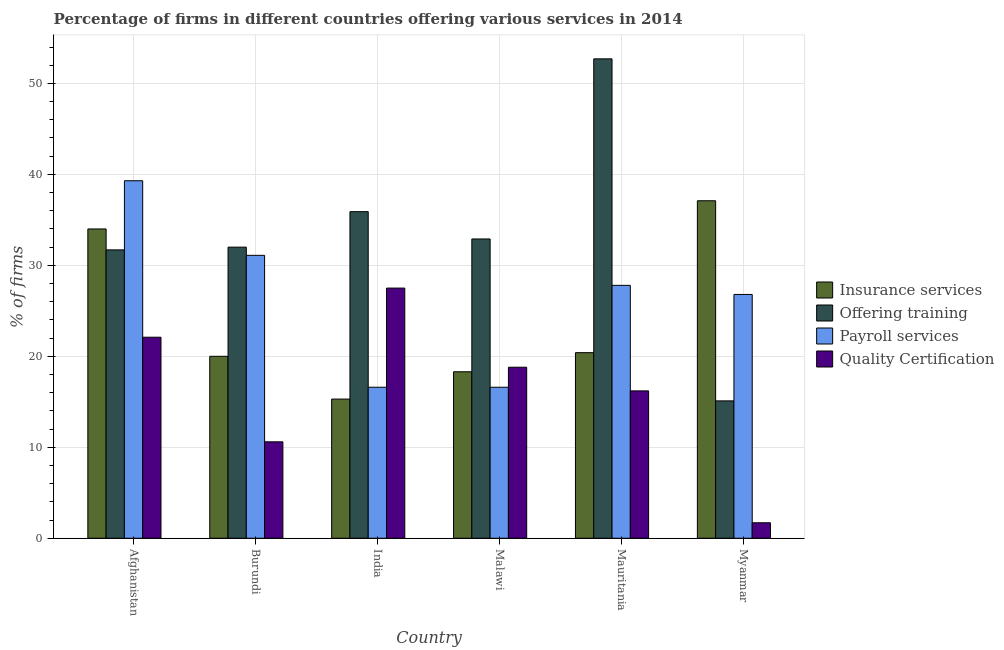Are the number of bars on each tick of the X-axis equal?
Your answer should be compact. Yes. What is the label of the 6th group of bars from the left?
Offer a terse response. Myanmar. What is the percentage of firms offering quality certification in Afghanistan?
Provide a short and direct response. 22.1. Across all countries, what is the maximum percentage of firms offering payroll services?
Your response must be concise. 39.3. Across all countries, what is the minimum percentage of firms offering insurance services?
Your answer should be compact. 15.3. In which country was the percentage of firms offering payroll services maximum?
Provide a succinct answer. Afghanistan. In which country was the percentage of firms offering training minimum?
Give a very brief answer. Myanmar. What is the total percentage of firms offering insurance services in the graph?
Keep it short and to the point. 145.1. What is the difference between the percentage of firms offering training in Burundi and that in India?
Your response must be concise. -3.9. What is the difference between the percentage of firms offering payroll services in Burundi and the percentage of firms offering quality certification in Myanmar?
Your answer should be very brief. 29.4. What is the average percentage of firms offering payroll services per country?
Your answer should be compact. 26.37. What is the difference between the percentage of firms offering quality certification and percentage of firms offering training in India?
Make the answer very short. -8.4. In how many countries, is the percentage of firms offering training greater than 4 %?
Your answer should be compact. 6. What is the ratio of the percentage of firms offering training in Burundi to that in Malawi?
Your response must be concise. 0.97. Is the percentage of firms offering training in Burundi less than that in India?
Give a very brief answer. Yes. What is the difference between the highest and the second highest percentage of firms offering training?
Make the answer very short. 16.8. What is the difference between the highest and the lowest percentage of firms offering training?
Ensure brevity in your answer.  37.6. What does the 2nd bar from the left in India represents?
Make the answer very short. Offering training. What does the 2nd bar from the right in Mauritania represents?
Ensure brevity in your answer.  Payroll services. Is it the case that in every country, the sum of the percentage of firms offering insurance services and percentage of firms offering training is greater than the percentage of firms offering payroll services?
Offer a terse response. Yes. How many bars are there?
Make the answer very short. 24. Are all the bars in the graph horizontal?
Ensure brevity in your answer.  No. How many countries are there in the graph?
Your answer should be compact. 6. Are the values on the major ticks of Y-axis written in scientific E-notation?
Offer a very short reply. No. Where does the legend appear in the graph?
Your answer should be compact. Center right. What is the title of the graph?
Make the answer very short. Percentage of firms in different countries offering various services in 2014. What is the label or title of the X-axis?
Make the answer very short. Country. What is the label or title of the Y-axis?
Provide a short and direct response. % of firms. What is the % of firms in Insurance services in Afghanistan?
Provide a short and direct response. 34. What is the % of firms in Offering training in Afghanistan?
Keep it short and to the point. 31.7. What is the % of firms of Payroll services in Afghanistan?
Ensure brevity in your answer.  39.3. What is the % of firms in Quality Certification in Afghanistan?
Offer a very short reply. 22.1. What is the % of firms in Insurance services in Burundi?
Provide a succinct answer. 20. What is the % of firms in Payroll services in Burundi?
Ensure brevity in your answer.  31.1. What is the % of firms of Insurance services in India?
Provide a short and direct response. 15.3. What is the % of firms in Offering training in India?
Keep it short and to the point. 35.9. What is the % of firms of Quality Certification in India?
Your answer should be compact. 27.5. What is the % of firms in Offering training in Malawi?
Give a very brief answer. 32.9. What is the % of firms of Insurance services in Mauritania?
Your answer should be very brief. 20.4. What is the % of firms of Offering training in Mauritania?
Your answer should be compact. 52.7. What is the % of firms of Payroll services in Mauritania?
Make the answer very short. 27.8. What is the % of firms of Quality Certification in Mauritania?
Provide a succinct answer. 16.2. What is the % of firms in Insurance services in Myanmar?
Keep it short and to the point. 37.1. What is the % of firms of Payroll services in Myanmar?
Ensure brevity in your answer.  26.8. What is the % of firms in Quality Certification in Myanmar?
Your answer should be very brief. 1.7. Across all countries, what is the maximum % of firms of Insurance services?
Offer a very short reply. 37.1. Across all countries, what is the maximum % of firms of Offering training?
Your answer should be very brief. 52.7. Across all countries, what is the maximum % of firms in Payroll services?
Ensure brevity in your answer.  39.3. Across all countries, what is the minimum % of firms of Insurance services?
Ensure brevity in your answer.  15.3. Across all countries, what is the minimum % of firms of Offering training?
Your answer should be very brief. 15.1. Across all countries, what is the minimum % of firms in Payroll services?
Ensure brevity in your answer.  16.6. What is the total % of firms of Insurance services in the graph?
Your answer should be compact. 145.1. What is the total % of firms of Offering training in the graph?
Keep it short and to the point. 200.3. What is the total % of firms of Payroll services in the graph?
Offer a very short reply. 158.2. What is the total % of firms of Quality Certification in the graph?
Your response must be concise. 96.9. What is the difference between the % of firms in Insurance services in Afghanistan and that in Burundi?
Offer a terse response. 14. What is the difference between the % of firms of Offering training in Afghanistan and that in Burundi?
Provide a succinct answer. -0.3. What is the difference between the % of firms of Payroll services in Afghanistan and that in Burundi?
Your answer should be compact. 8.2. What is the difference between the % of firms in Offering training in Afghanistan and that in India?
Your answer should be compact. -4.2. What is the difference between the % of firms in Payroll services in Afghanistan and that in India?
Your answer should be compact. 22.7. What is the difference between the % of firms of Insurance services in Afghanistan and that in Malawi?
Make the answer very short. 15.7. What is the difference between the % of firms in Payroll services in Afghanistan and that in Malawi?
Give a very brief answer. 22.7. What is the difference between the % of firms in Insurance services in Afghanistan and that in Mauritania?
Ensure brevity in your answer.  13.6. What is the difference between the % of firms in Offering training in Afghanistan and that in Mauritania?
Ensure brevity in your answer.  -21. What is the difference between the % of firms of Quality Certification in Afghanistan and that in Mauritania?
Ensure brevity in your answer.  5.9. What is the difference between the % of firms in Insurance services in Afghanistan and that in Myanmar?
Give a very brief answer. -3.1. What is the difference between the % of firms of Offering training in Afghanistan and that in Myanmar?
Give a very brief answer. 16.6. What is the difference between the % of firms of Quality Certification in Afghanistan and that in Myanmar?
Keep it short and to the point. 20.4. What is the difference between the % of firms of Payroll services in Burundi and that in India?
Your answer should be compact. 14.5. What is the difference between the % of firms in Quality Certification in Burundi and that in India?
Provide a succinct answer. -16.9. What is the difference between the % of firms in Quality Certification in Burundi and that in Malawi?
Make the answer very short. -8.2. What is the difference between the % of firms in Offering training in Burundi and that in Mauritania?
Provide a succinct answer. -20.7. What is the difference between the % of firms of Payroll services in Burundi and that in Mauritania?
Provide a short and direct response. 3.3. What is the difference between the % of firms in Insurance services in Burundi and that in Myanmar?
Make the answer very short. -17.1. What is the difference between the % of firms of Quality Certification in Burundi and that in Myanmar?
Give a very brief answer. 8.9. What is the difference between the % of firms in Offering training in India and that in Malawi?
Provide a succinct answer. 3. What is the difference between the % of firms in Quality Certification in India and that in Malawi?
Ensure brevity in your answer.  8.7. What is the difference between the % of firms of Offering training in India and that in Mauritania?
Offer a terse response. -16.8. What is the difference between the % of firms in Quality Certification in India and that in Mauritania?
Give a very brief answer. 11.3. What is the difference between the % of firms in Insurance services in India and that in Myanmar?
Make the answer very short. -21.8. What is the difference between the % of firms in Offering training in India and that in Myanmar?
Make the answer very short. 20.8. What is the difference between the % of firms in Payroll services in India and that in Myanmar?
Ensure brevity in your answer.  -10.2. What is the difference between the % of firms of Quality Certification in India and that in Myanmar?
Provide a short and direct response. 25.8. What is the difference between the % of firms in Insurance services in Malawi and that in Mauritania?
Keep it short and to the point. -2.1. What is the difference between the % of firms in Offering training in Malawi and that in Mauritania?
Give a very brief answer. -19.8. What is the difference between the % of firms of Payroll services in Malawi and that in Mauritania?
Your answer should be compact. -11.2. What is the difference between the % of firms of Insurance services in Malawi and that in Myanmar?
Give a very brief answer. -18.8. What is the difference between the % of firms of Offering training in Malawi and that in Myanmar?
Your response must be concise. 17.8. What is the difference between the % of firms in Payroll services in Malawi and that in Myanmar?
Ensure brevity in your answer.  -10.2. What is the difference between the % of firms of Quality Certification in Malawi and that in Myanmar?
Offer a terse response. 17.1. What is the difference between the % of firms of Insurance services in Mauritania and that in Myanmar?
Provide a short and direct response. -16.7. What is the difference between the % of firms in Offering training in Mauritania and that in Myanmar?
Give a very brief answer. 37.6. What is the difference between the % of firms in Payroll services in Mauritania and that in Myanmar?
Keep it short and to the point. 1. What is the difference between the % of firms of Insurance services in Afghanistan and the % of firms of Quality Certification in Burundi?
Ensure brevity in your answer.  23.4. What is the difference between the % of firms in Offering training in Afghanistan and the % of firms in Quality Certification in Burundi?
Offer a terse response. 21.1. What is the difference between the % of firms of Payroll services in Afghanistan and the % of firms of Quality Certification in Burundi?
Offer a terse response. 28.7. What is the difference between the % of firms of Offering training in Afghanistan and the % of firms of Quality Certification in India?
Keep it short and to the point. 4.2. What is the difference between the % of firms in Payroll services in Afghanistan and the % of firms in Quality Certification in India?
Offer a terse response. 11.8. What is the difference between the % of firms of Insurance services in Afghanistan and the % of firms of Offering training in Malawi?
Provide a succinct answer. 1.1. What is the difference between the % of firms in Insurance services in Afghanistan and the % of firms in Payroll services in Malawi?
Offer a terse response. 17.4. What is the difference between the % of firms in Insurance services in Afghanistan and the % of firms in Quality Certification in Malawi?
Your answer should be compact. 15.2. What is the difference between the % of firms in Payroll services in Afghanistan and the % of firms in Quality Certification in Malawi?
Your answer should be very brief. 20.5. What is the difference between the % of firms of Insurance services in Afghanistan and the % of firms of Offering training in Mauritania?
Provide a short and direct response. -18.7. What is the difference between the % of firms of Payroll services in Afghanistan and the % of firms of Quality Certification in Mauritania?
Provide a short and direct response. 23.1. What is the difference between the % of firms in Insurance services in Afghanistan and the % of firms in Offering training in Myanmar?
Your answer should be very brief. 18.9. What is the difference between the % of firms of Insurance services in Afghanistan and the % of firms of Payroll services in Myanmar?
Offer a very short reply. 7.2. What is the difference between the % of firms of Insurance services in Afghanistan and the % of firms of Quality Certification in Myanmar?
Offer a very short reply. 32.3. What is the difference between the % of firms of Offering training in Afghanistan and the % of firms of Payroll services in Myanmar?
Your answer should be compact. 4.9. What is the difference between the % of firms in Payroll services in Afghanistan and the % of firms in Quality Certification in Myanmar?
Offer a very short reply. 37.6. What is the difference between the % of firms of Insurance services in Burundi and the % of firms of Offering training in India?
Provide a succinct answer. -15.9. What is the difference between the % of firms of Offering training in Burundi and the % of firms of Payroll services in Malawi?
Keep it short and to the point. 15.4. What is the difference between the % of firms of Offering training in Burundi and the % of firms of Quality Certification in Malawi?
Ensure brevity in your answer.  13.2. What is the difference between the % of firms in Insurance services in Burundi and the % of firms in Offering training in Mauritania?
Provide a short and direct response. -32.7. What is the difference between the % of firms in Insurance services in Burundi and the % of firms in Payroll services in Mauritania?
Give a very brief answer. -7.8. What is the difference between the % of firms of Offering training in Burundi and the % of firms of Payroll services in Mauritania?
Provide a succinct answer. 4.2. What is the difference between the % of firms in Offering training in Burundi and the % of firms in Quality Certification in Mauritania?
Ensure brevity in your answer.  15.8. What is the difference between the % of firms in Payroll services in Burundi and the % of firms in Quality Certification in Mauritania?
Provide a succinct answer. 14.9. What is the difference between the % of firms of Insurance services in Burundi and the % of firms of Payroll services in Myanmar?
Offer a very short reply. -6.8. What is the difference between the % of firms of Offering training in Burundi and the % of firms of Quality Certification in Myanmar?
Keep it short and to the point. 30.3. What is the difference between the % of firms in Payroll services in Burundi and the % of firms in Quality Certification in Myanmar?
Provide a succinct answer. 29.4. What is the difference between the % of firms of Insurance services in India and the % of firms of Offering training in Malawi?
Give a very brief answer. -17.6. What is the difference between the % of firms of Offering training in India and the % of firms of Payroll services in Malawi?
Provide a short and direct response. 19.3. What is the difference between the % of firms of Offering training in India and the % of firms of Quality Certification in Malawi?
Your answer should be very brief. 17.1. What is the difference between the % of firms of Payroll services in India and the % of firms of Quality Certification in Malawi?
Give a very brief answer. -2.2. What is the difference between the % of firms of Insurance services in India and the % of firms of Offering training in Mauritania?
Make the answer very short. -37.4. What is the difference between the % of firms in Insurance services in India and the % of firms in Payroll services in Mauritania?
Provide a succinct answer. -12.5. What is the difference between the % of firms of Insurance services in India and the % of firms of Quality Certification in Mauritania?
Provide a succinct answer. -0.9. What is the difference between the % of firms of Offering training in India and the % of firms of Quality Certification in Mauritania?
Your response must be concise. 19.7. What is the difference between the % of firms in Insurance services in India and the % of firms in Offering training in Myanmar?
Make the answer very short. 0.2. What is the difference between the % of firms in Insurance services in India and the % of firms in Payroll services in Myanmar?
Your answer should be very brief. -11.5. What is the difference between the % of firms in Offering training in India and the % of firms in Payroll services in Myanmar?
Keep it short and to the point. 9.1. What is the difference between the % of firms in Offering training in India and the % of firms in Quality Certification in Myanmar?
Keep it short and to the point. 34.2. What is the difference between the % of firms in Payroll services in India and the % of firms in Quality Certification in Myanmar?
Provide a succinct answer. 14.9. What is the difference between the % of firms in Insurance services in Malawi and the % of firms in Offering training in Mauritania?
Make the answer very short. -34.4. What is the difference between the % of firms in Insurance services in Malawi and the % of firms in Payroll services in Mauritania?
Your response must be concise. -9.5. What is the difference between the % of firms of Insurance services in Malawi and the % of firms of Quality Certification in Mauritania?
Keep it short and to the point. 2.1. What is the difference between the % of firms in Offering training in Malawi and the % of firms in Quality Certification in Mauritania?
Your answer should be very brief. 16.7. What is the difference between the % of firms in Insurance services in Malawi and the % of firms in Quality Certification in Myanmar?
Ensure brevity in your answer.  16.6. What is the difference between the % of firms of Offering training in Malawi and the % of firms of Quality Certification in Myanmar?
Your response must be concise. 31.2. What is the difference between the % of firms in Insurance services in Mauritania and the % of firms in Payroll services in Myanmar?
Ensure brevity in your answer.  -6.4. What is the difference between the % of firms of Offering training in Mauritania and the % of firms of Payroll services in Myanmar?
Provide a short and direct response. 25.9. What is the difference between the % of firms in Offering training in Mauritania and the % of firms in Quality Certification in Myanmar?
Make the answer very short. 51. What is the difference between the % of firms in Payroll services in Mauritania and the % of firms in Quality Certification in Myanmar?
Ensure brevity in your answer.  26.1. What is the average % of firms in Insurance services per country?
Make the answer very short. 24.18. What is the average % of firms in Offering training per country?
Your response must be concise. 33.38. What is the average % of firms in Payroll services per country?
Your response must be concise. 26.37. What is the average % of firms of Quality Certification per country?
Ensure brevity in your answer.  16.15. What is the difference between the % of firms in Insurance services and % of firms in Offering training in Afghanistan?
Offer a very short reply. 2.3. What is the difference between the % of firms of Insurance services and % of firms of Quality Certification in Afghanistan?
Make the answer very short. 11.9. What is the difference between the % of firms in Offering training and % of firms in Payroll services in Afghanistan?
Your answer should be compact. -7.6. What is the difference between the % of firms of Insurance services and % of firms of Quality Certification in Burundi?
Make the answer very short. 9.4. What is the difference between the % of firms of Offering training and % of firms of Payroll services in Burundi?
Your response must be concise. 0.9. What is the difference between the % of firms in Offering training and % of firms in Quality Certification in Burundi?
Your answer should be compact. 21.4. What is the difference between the % of firms of Payroll services and % of firms of Quality Certification in Burundi?
Provide a succinct answer. 20.5. What is the difference between the % of firms in Insurance services and % of firms in Offering training in India?
Your answer should be compact. -20.6. What is the difference between the % of firms in Insurance services and % of firms in Payroll services in India?
Provide a succinct answer. -1.3. What is the difference between the % of firms in Insurance services and % of firms in Quality Certification in India?
Give a very brief answer. -12.2. What is the difference between the % of firms in Offering training and % of firms in Payroll services in India?
Give a very brief answer. 19.3. What is the difference between the % of firms of Offering training and % of firms of Quality Certification in India?
Provide a succinct answer. 8.4. What is the difference between the % of firms in Payroll services and % of firms in Quality Certification in India?
Your answer should be very brief. -10.9. What is the difference between the % of firms in Insurance services and % of firms in Offering training in Malawi?
Your answer should be very brief. -14.6. What is the difference between the % of firms in Insurance services and % of firms in Payroll services in Malawi?
Offer a very short reply. 1.7. What is the difference between the % of firms in Insurance services and % of firms in Quality Certification in Malawi?
Your response must be concise. -0.5. What is the difference between the % of firms of Offering training and % of firms of Payroll services in Malawi?
Offer a very short reply. 16.3. What is the difference between the % of firms of Insurance services and % of firms of Offering training in Mauritania?
Provide a short and direct response. -32.3. What is the difference between the % of firms in Insurance services and % of firms in Payroll services in Mauritania?
Keep it short and to the point. -7.4. What is the difference between the % of firms in Insurance services and % of firms in Quality Certification in Mauritania?
Your response must be concise. 4.2. What is the difference between the % of firms of Offering training and % of firms of Payroll services in Mauritania?
Make the answer very short. 24.9. What is the difference between the % of firms of Offering training and % of firms of Quality Certification in Mauritania?
Provide a short and direct response. 36.5. What is the difference between the % of firms in Payroll services and % of firms in Quality Certification in Mauritania?
Provide a succinct answer. 11.6. What is the difference between the % of firms of Insurance services and % of firms of Offering training in Myanmar?
Ensure brevity in your answer.  22. What is the difference between the % of firms in Insurance services and % of firms in Quality Certification in Myanmar?
Your answer should be compact. 35.4. What is the difference between the % of firms in Payroll services and % of firms in Quality Certification in Myanmar?
Keep it short and to the point. 25.1. What is the ratio of the % of firms of Offering training in Afghanistan to that in Burundi?
Provide a short and direct response. 0.99. What is the ratio of the % of firms in Payroll services in Afghanistan to that in Burundi?
Provide a short and direct response. 1.26. What is the ratio of the % of firms of Quality Certification in Afghanistan to that in Burundi?
Keep it short and to the point. 2.08. What is the ratio of the % of firms of Insurance services in Afghanistan to that in India?
Make the answer very short. 2.22. What is the ratio of the % of firms of Offering training in Afghanistan to that in India?
Ensure brevity in your answer.  0.88. What is the ratio of the % of firms in Payroll services in Afghanistan to that in India?
Offer a terse response. 2.37. What is the ratio of the % of firms in Quality Certification in Afghanistan to that in India?
Keep it short and to the point. 0.8. What is the ratio of the % of firms in Insurance services in Afghanistan to that in Malawi?
Provide a succinct answer. 1.86. What is the ratio of the % of firms in Offering training in Afghanistan to that in Malawi?
Offer a very short reply. 0.96. What is the ratio of the % of firms of Payroll services in Afghanistan to that in Malawi?
Provide a succinct answer. 2.37. What is the ratio of the % of firms of Quality Certification in Afghanistan to that in Malawi?
Provide a short and direct response. 1.18. What is the ratio of the % of firms of Insurance services in Afghanistan to that in Mauritania?
Offer a terse response. 1.67. What is the ratio of the % of firms in Offering training in Afghanistan to that in Mauritania?
Your answer should be very brief. 0.6. What is the ratio of the % of firms in Payroll services in Afghanistan to that in Mauritania?
Offer a terse response. 1.41. What is the ratio of the % of firms in Quality Certification in Afghanistan to that in Mauritania?
Provide a succinct answer. 1.36. What is the ratio of the % of firms of Insurance services in Afghanistan to that in Myanmar?
Offer a very short reply. 0.92. What is the ratio of the % of firms of Offering training in Afghanistan to that in Myanmar?
Make the answer very short. 2.1. What is the ratio of the % of firms of Payroll services in Afghanistan to that in Myanmar?
Ensure brevity in your answer.  1.47. What is the ratio of the % of firms in Quality Certification in Afghanistan to that in Myanmar?
Your answer should be very brief. 13. What is the ratio of the % of firms in Insurance services in Burundi to that in India?
Keep it short and to the point. 1.31. What is the ratio of the % of firms in Offering training in Burundi to that in India?
Your answer should be very brief. 0.89. What is the ratio of the % of firms in Payroll services in Burundi to that in India?
Give a very brief answer. 1.87. What is the ratio of the % of firms of Quality Certification in Burundi to that in India?
Provide a short and direct response. 0.39. What is the ratio of the % of firms of Insurance services in Burundi to that in Malawi?
Make the answer very short. 1.09. What is the ratio of the % of firms in Offering training in Burundi to that in Malawi?
Your answer should be very brief. 0.97. What is the ratio of the % of firms in Payroll services in Burundi to that in Malawi?
Your answer should be very brief. 1.87. What is the ratio of the % of firms of Quality Certification in Burundi to that in Malawi?
Your response must be concise. 0.56. What is the ratio of the % of firms of Insurance services in Burundi to that in Mauritania?
Your answer should be compact. 0.98. What is the ratio of the % of firms of Offering training in Burundi to that in Mauritania?
Ensure brevity in your answer.  0.61. What is the ratio of the % of firms in Payroll services in Burundi to that in Mauritania?
Give a very brief answer. 1.12. What is the ratio of the % of firms of Quality Certification in Burundi to that in Mauritania?
Provide a succinct answer. 0.65. What is the ratio of the % of firms in Insurance services in Burundi to that in Myanmar?
Provide a succinct answer. 0.54. What is the ratio of the % of firms of Offering training in Burundi to that in Myanmar?
Offer a very short reply. 2.12. What is the ratio of the % of firms in Payroll services in Burundi to that in Myanmar?
Provide a short and direct response. 1.16. What is the ratio of the % of firms in Quality Certification in Burundi to that in Myanmar?
Provide a short and direct response. 6.24. What is the ratio of the % of firms of Insurance services in India to that in Malawi?
Offer a very short reply. 0.84. What is the ratio of the % of firms of Offering training in India to that in Malawi?
Provide a succinct answer. 1.09. What is the ratio of the % of firms of Payroll services in India to that in Malawi?
Your answer should be compact. 1. What is the ratio of the % of firms of Quality Certification in India to that in Malawi?
Provide a short and direct response. 1.46. What is the ratio of the % of firms of Insurance services in India to that in Mauritania?
Make the answer very short. 0.75. What is the ratio of the % of firms of Offering training in India to that in Mauritania?
Offer a very short reply. 0.68. What is the ratio of the % of firms in Payroll services in India to that in Mauritania?
Your answer should be very brief. 0.6. What is the ratio of the % of firms in Quality Certification in India to that in Mauritania?
Provide a short and direct response. 1.7. What is the ratio of the % of firms in Insurance services in India to that in Myanmar?
Ensure brevity in your answer.  0.41. What is the ratio of the % of firms in Offering training in India to that in Myanmar?
Keep it short and to the point. 2.38. What is the ratio of the % of firms in Payroll services in India to that in Myanmar?
Your answer should be very brief. 0.62. What is the ratio of the % of firms in Quality Certification in India to that in Myanmar?
Your answer should be very brief. 16.18. What is the ratio of the % of firms in Insurance services in Malawi to that in Mauritania?
Your answer should be compact. 0.9. What is the ratio of the % of firms of Offering training in Malawi to that in Mauritania?
Offer a terse response. 0.62. What is the ratio of the % of firms in Payroll services in Malawi to that in Mauritania?
Provide a short and direct response. 0.6. What is the ratio of the % of firms of Quality Certification in Malawi to that in Mauritania?
Ensure brevity in your answer.  1.16. What is the ratio of the % of firms in Insurance services in Malawi to that in Myanmar?
Offer a very short reply. 0.49. What is the ratio of the % of firms of Offering training in Malawi to that in Myanmar?
Offer a very short reply. 2.18. What is the ratio of the % of firms of Payroll services in Malawi to that in Myanmar?
Provide a short and direct response. 0.62. What is the ratio of the % of firms in Quality Certification in Malawi to that in Myanmar?
Provide a succinct answer. 11.06. What is the ratio of the % of firms of Insurance services in Mauritania to that in Myanmar?
Give a very brief answer. 0.55. What is the ratio of the % of firms of Offering training in Mauritania to that in Myanmar?
Make the answer very short. 3.49. What is the ratio of the % of firms in Payroll services in Mauritania to that in Myanmar?
Your answer should be compact. 1.04. What is the ratio of the % of firms of Quality Certification in Mauritania to that in Myanmar?
Keep it short and to the point. 9.53. What is the difference between the highest and the second highest % of firms in Insurance services?
Your response must be concise. 3.1. What is the difference between the highest and the second highest % of firms of Payroll services?
Provide a succinct answer. 8.2. What is the difference between the highest and the lowest % of firms of Insurance services?
Provide a succinct answer. 21.8. What is the difference between the highest and the lowest % of firms in Offering training?
Give a very brief answer. 37.6. What is the difference between the highest and the lowest % of firms in Payroll services?
Your answer should be compact. 22.7. What is the difference between the highest and the lowest % of firms of Quality Certification?
Ensure brevity in your answer.  25.8. 